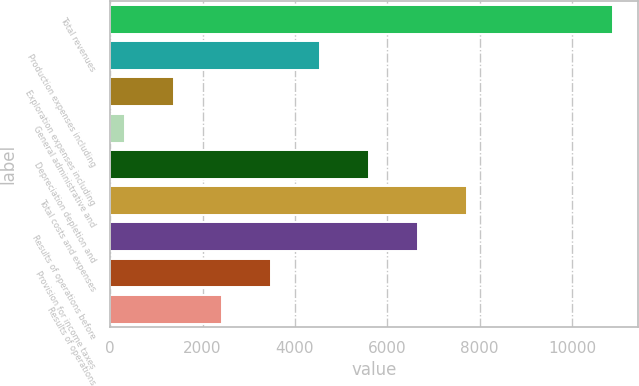Convert chart. <chart><loc_0><loc_0><loc_500><loc_500><bar_chart><fcel>Total revenues<fcel>Production expenses including<fcel>Exploration expenses including<fcel>General administrative and<fcel>Depreciation depletion and<fcel>Total costs and expenses<fcel>Results of operations before<fcel>Provision for income taxes<fcel>Results of operations<nl><fcel>10893<fcel>4545.6<fcel>1371.9<fcel>314<fcel>5603.5<fcel>7719.3<fcel>6661.4<fcel>3487.7<fcel>2429.8<nl></chart> 